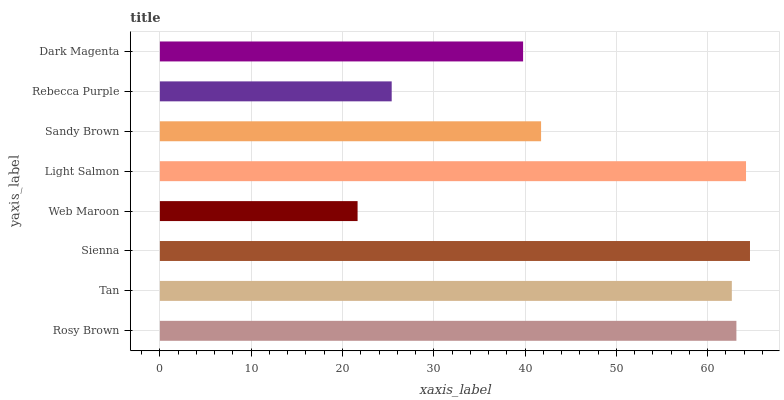Is Web Maroon the minimum?
Answer yes or no. Yes. Is Sienna the maximum?
Answer yes or no. Yes. Is Tan the minimum?
Answer yes or no. No. Is Tan the maximum?
Answer yes or no. No. Is Rosy Brown greater than Tan?
Answer yes or no. Yes. Is Tan less than Rosy Brown?
Answer yes or no. Yes. Is Tan greater than Rosy Brown?
Answer yes or no. No. Is Rosy Brown less than Tan?
Answer yes or no. No. Is Tan the high median?
Answer yes or no. Yes. Is Sandy Brown the low median?
Answer yes or no. Yes. Is Sienna the high median?
Answer yes or no. No. Is Light Salmon the low median?
Answer yes or no. No. 